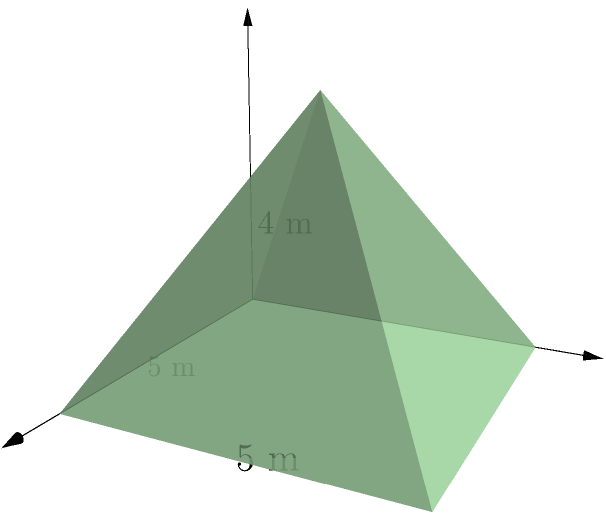As part of the rebuilding efforts in your village, you need to construct pyramidal roofs for new houses. Each roof has a square base with sides measuring 5 meters and a height of 4 meters. Calculate the total surface area of the roof, including the base, to determine the amount of materials needed for construction. Round your answer to the nearest square meter. To find the total surface area of the pyramidal roof, we need to calculate the area of the square base and the four triangular faces, then sum them up.

Step 1: Calculate the area of the square base.
Base area = $5^2 = 25$ m²

Step 2: Calculate the area of one triangular face.
First, we need to find the slant height of the pyramid using the Pythagorean theorem:
$l^2 = (\frac{5\sqrt{2}}{2})^2 + 4^2$, where $\frac{5\sqrt{2}}{2}$ is half the diagonal of the base.
$l^2 = \frac{50}{2} + 16 = 25 + 16 = 41$
$l = \sqrt{41}$ m

Now, we can calculate the area of one triangular face:
Area of one face = $\frac{1}{2} \times 5 \times \sqrt{41}$ m²

Step 3: Calculate the total area of the four triangular faces.
Total area of faces = $4 \times \frac{1}{2} \times 5 \times \sqrt{41} = 10\sqrt{41}$ m²

Step 4: Sum up the areas to get the total surface area.
Total surface area = Base area + Total area of faces
$= 25 + 10\sqrt{41}$ m²
$\approx 25 + 64.03 = 89.03$ m²

Step 5: Round to the nearest square meter.
89.03 m² rounds to 89 m²
Answer: 89 m² 